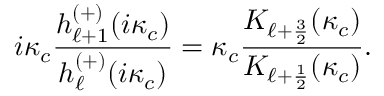Convert formula to latex. <formula><loc_0><loc_0><loc_500><loc_500>i \kappa _ { c } \frac { h _ { \ell + 1 } ^ { ( + ) } ( i \kappa _ { c } ) } { h _ { \ell } ^ { ( + ) } ( i \kappa _ { c } ) } = \kappa _ { c } \frac { K _ { \ell + \frac { 3 } { 2 } } ( \kappa _ { c } ) } { K _ { \ell + \frac { 1 } { 2 } } ( \kappa _ { c } ) } .</formula> 